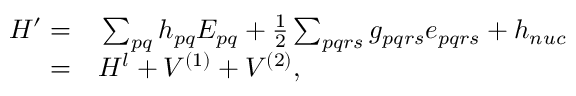Convert formula to latex. <formula><loc_0><loc_0><loc_500><loc_500>\begin{array} { r l } { H ^ { \prime } = } & \sum _ { p q } h _ { p q } E _ { p q } + \frac { 1 } { 2 } \sum _ { p q r s } g _ { p q r s } e _ { p q r s } + h _ { n u c } } \\ { = } & H ^ { l } + V ^ { ( 1 ) } + V ^ { ( 2 ) } , } \end{array}</formula> 